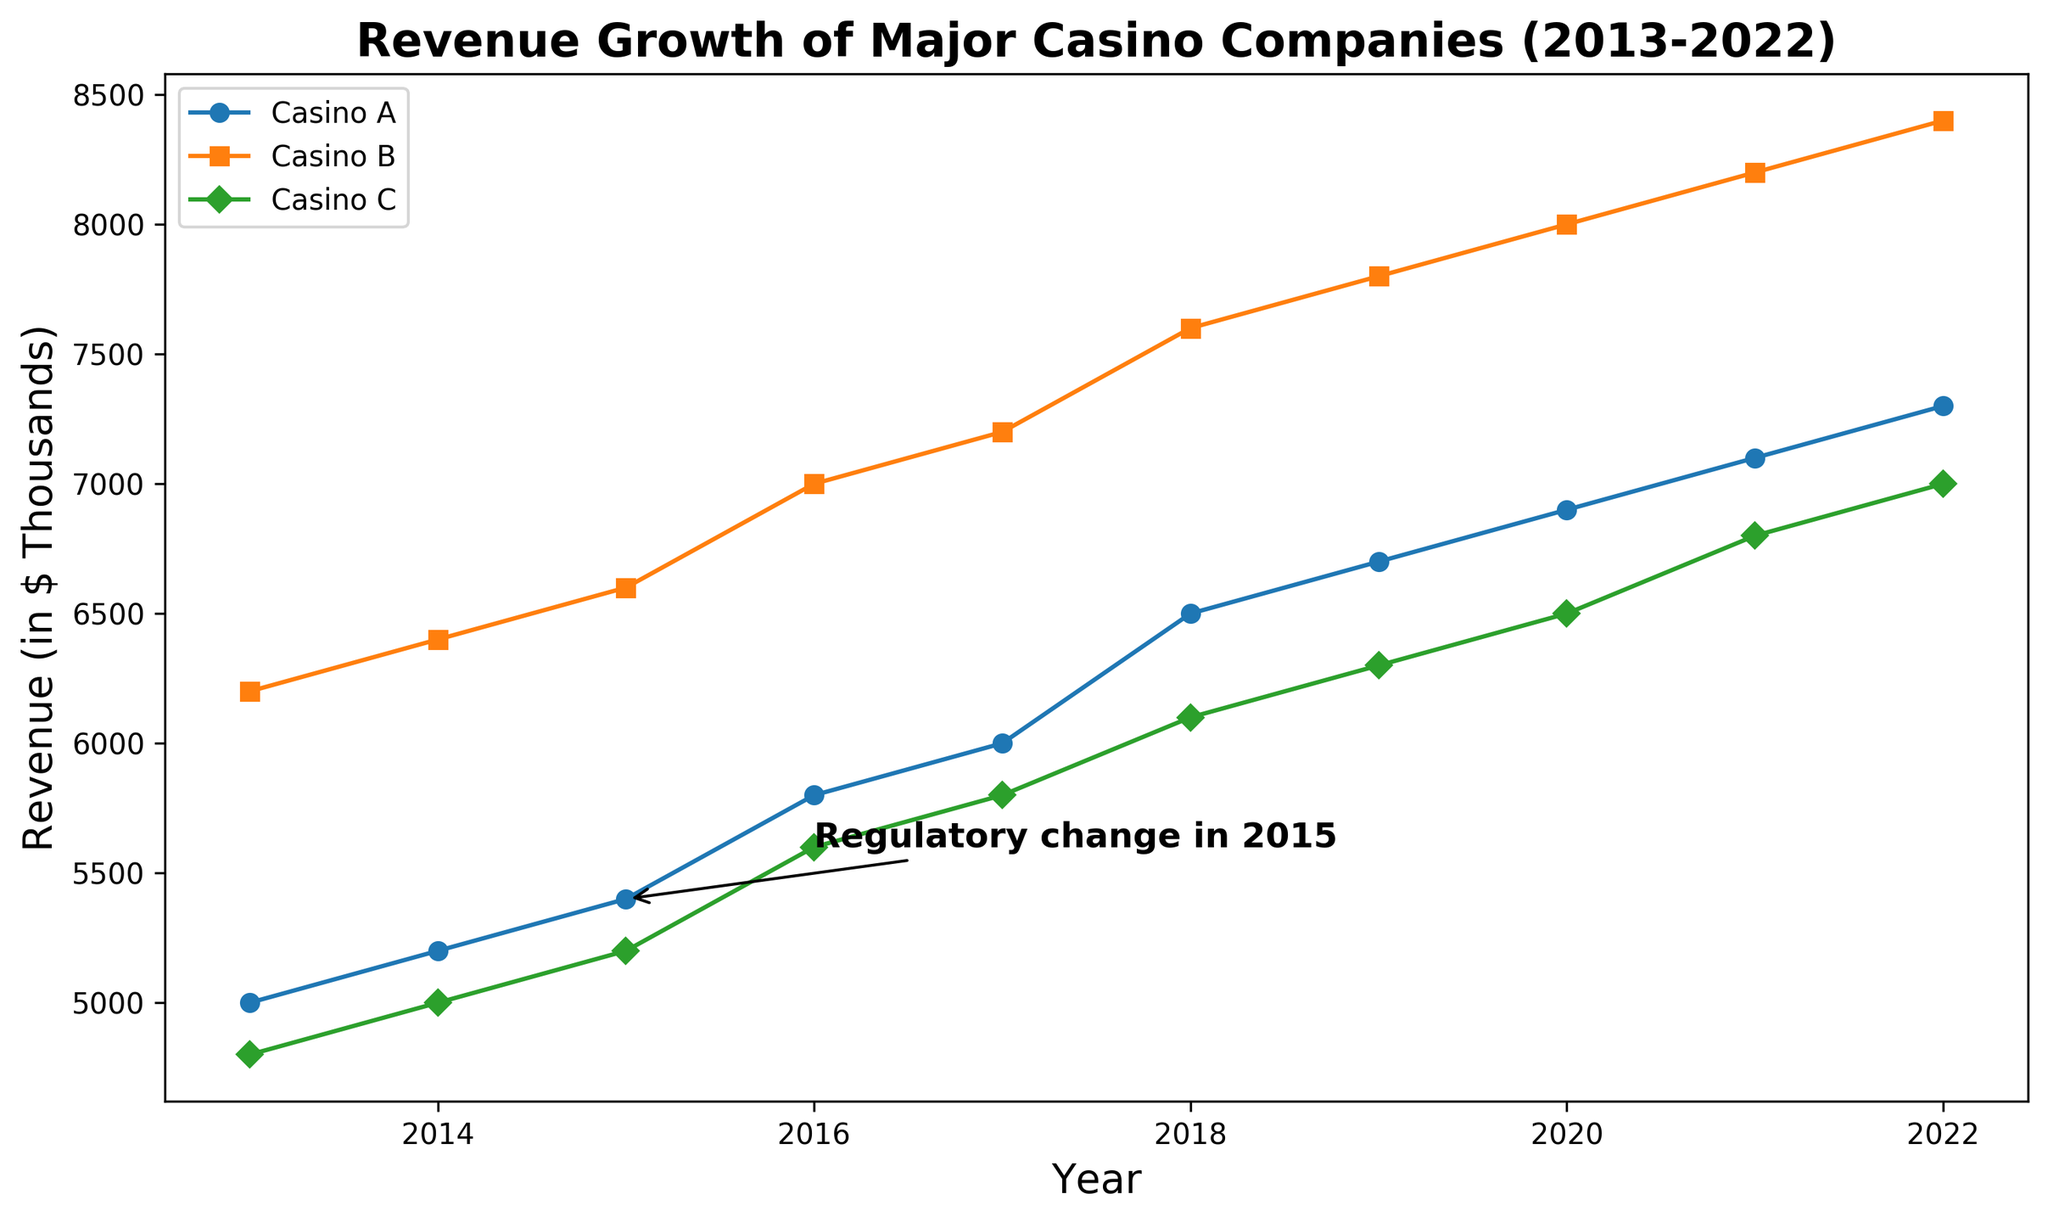What year did Casino A show its first revenue increase since 2013? The figure shows the revenue lines for each casino from 2013 to 2022. We need to look at Casino A's line and identify the first year after 2013 where its revenue increased from the previous year. In 2014, Casino A's revenue increased from 5000 to 5200.
Answer: 2014 How did the regulatory change in 2015 affect Casino B's revenue? The annotation in the figure marks the regulatory change in 2015. Looking at Casino B's revenue line, we see that its revenue increased from 6400 in 2014 to 6600 in 2015, indicating a positive impact on revenue.
Answer: Increased Which casino had the highest revenue in 2020? To answer this, we need to observe the revenue values for all three casinos in 2020. The figure shows that Casino B had a revenue of 8000, which is higher than Casino A (6900) and Casino C (6500).
Answer: Casino B Between which consecutive years did Casino C experience its largest revenue increase? To find the largest increase, compare the revenue of Casino C year-by-year and calculate the differences. The largest increase is between 2021 (6800) and 2022 (7000), with an increase of 200.
Answer: 2021-2022 Compare the revenue trends of Casino A and Casino C from 2015 to 2018. Looking at the revenue lines from 2015 to 2018, both Casino A and Casino C show an upward trend, but Casino A’s revenue increases more sharply from 5400 to 6500, whereas Casino C’s revenue increases more moderately from 5200 to 6100.
Answer: Both increased, but Casino A increased more sharply What's the difference in revenue between Casino B and Casino A in 2015? The figure shows that in 2015, the revenue of Casino B is 6600, and Casino A's revenue is 5400. The difference is 6600 - 5400.
Answer: 1200 During which year did all casinos show an increase in revenue compared to the previous year? Examining the year-to-year changes for all three casinos' revenue lines, the year 2015 shows all casinos (A, B, and C) increased their revenue from the previous year.
Answer: 2015 In the year marked with a regulatory change, what was the median revenue of the three casinos? The annotation marks the year 2015 with a regulatory change. The revenues in 2015 were 5400, 6600, and 5200. The median of these three values is the middle value when arranged in order: 5200, 5400, 6600.
Answer: 5400 How did the revenue of Casino A change from 2013 to 2022? By comparing the figures at the start (2013) and end (2022) for Casino A, we see an increase from 5000 in 2013 to 7300 in 2022.
Answer: Increased Which casino experienced the most consistent revenue growth from 2013 to 2022? By observing the revenue lines' slopes, Casino B shows the most consistent year-over-year increase without any declines, indicating the most steady growth.
Answer: Casino B 